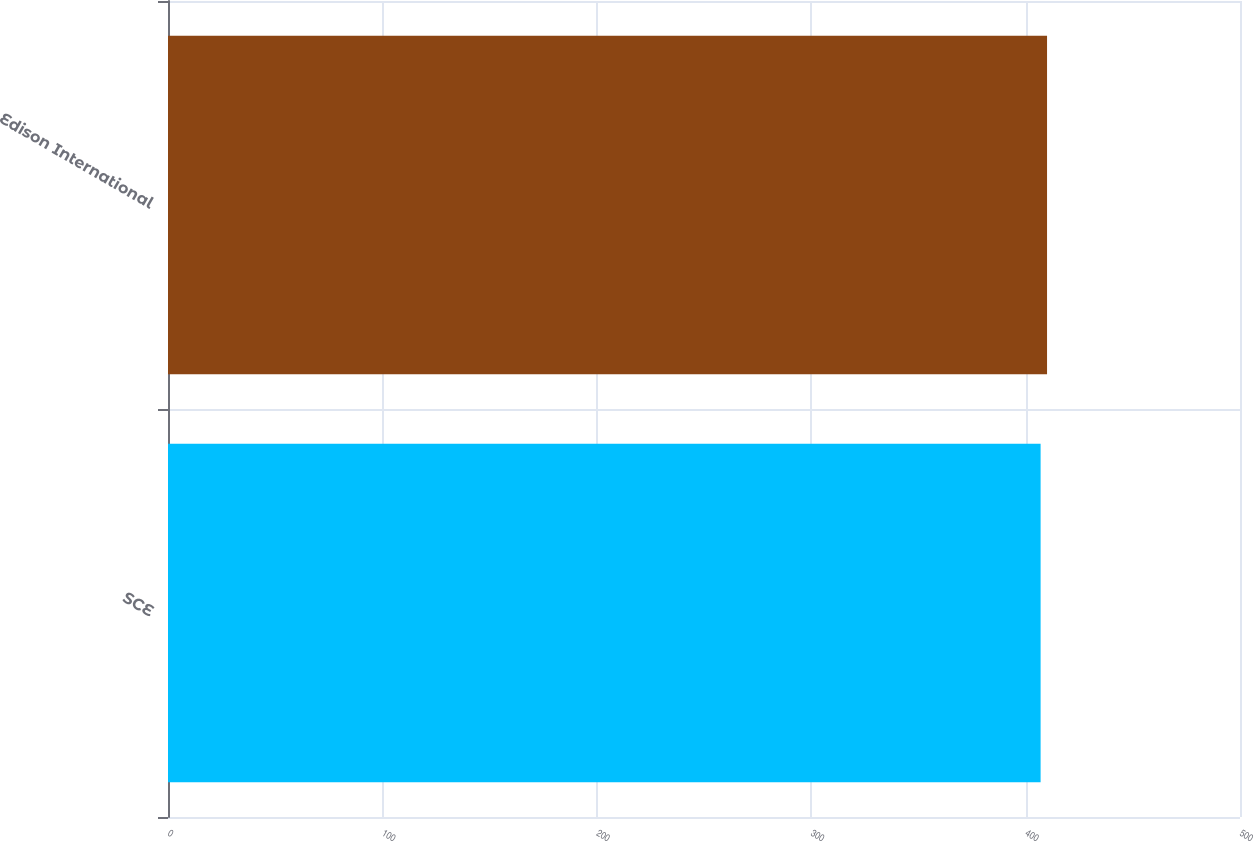Convert chart to OTSL. <chart><loc_0><loc_0><loc_500><loc_500><bar_chart><fcel>SCE<fcel>Edison International<nl><fcel>407<fcel>410<nl></chart> 